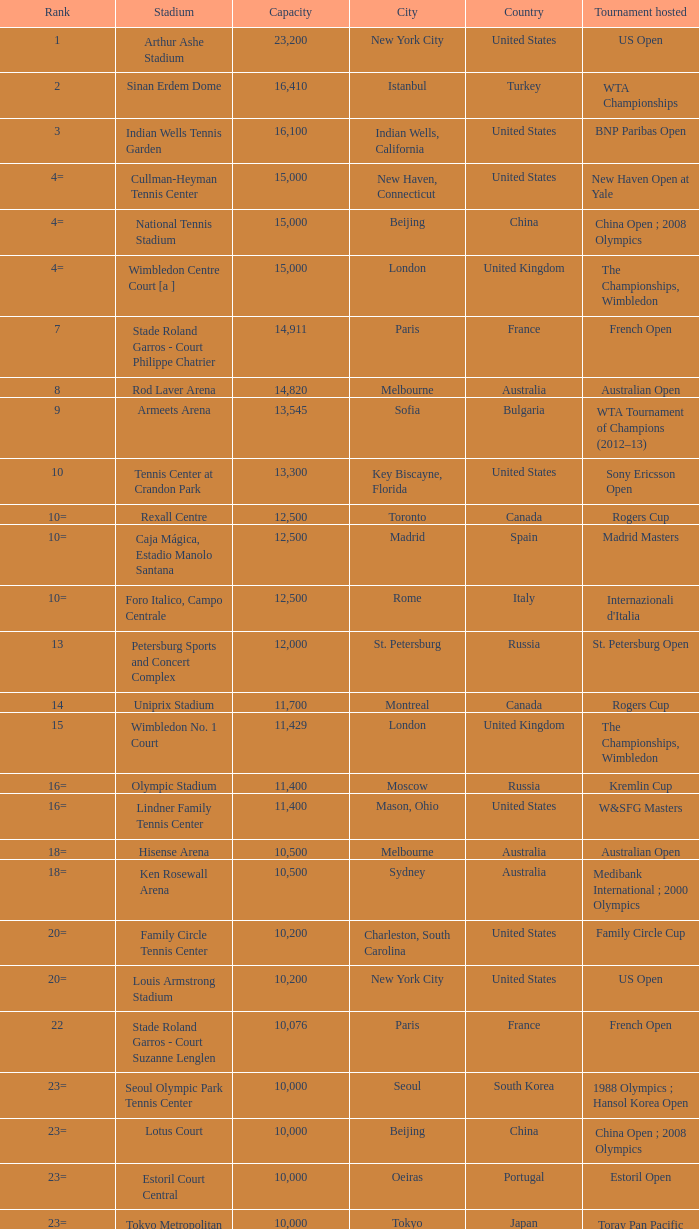What is the average capacity that has switzerland as the country? 6000.0. 